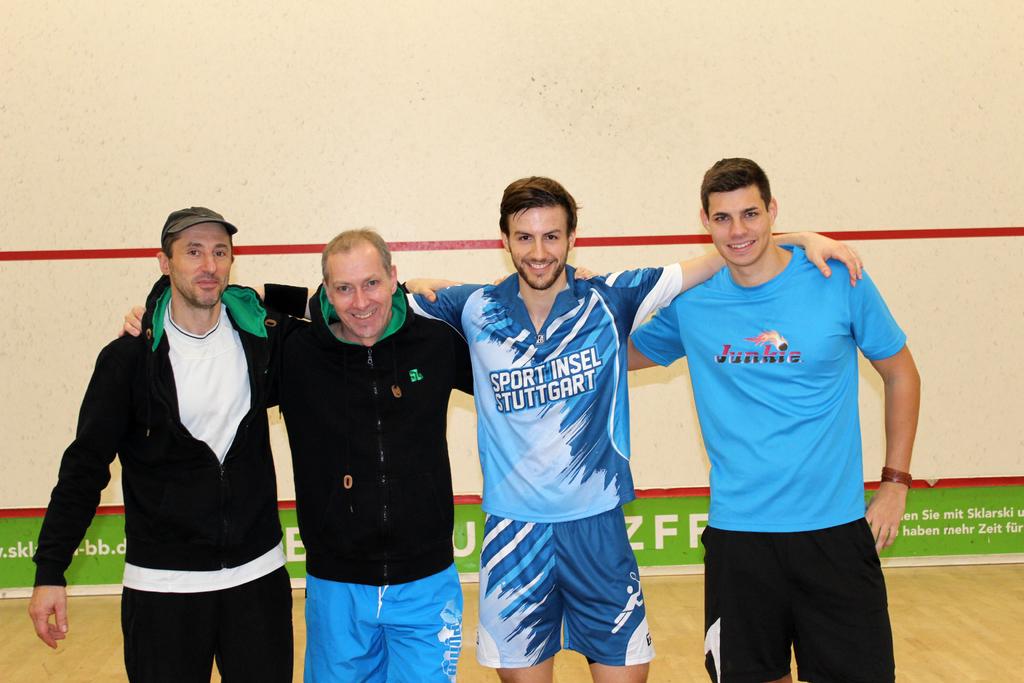What does blue shirt on far right say?
Your answer should be very brief. Junkie. 